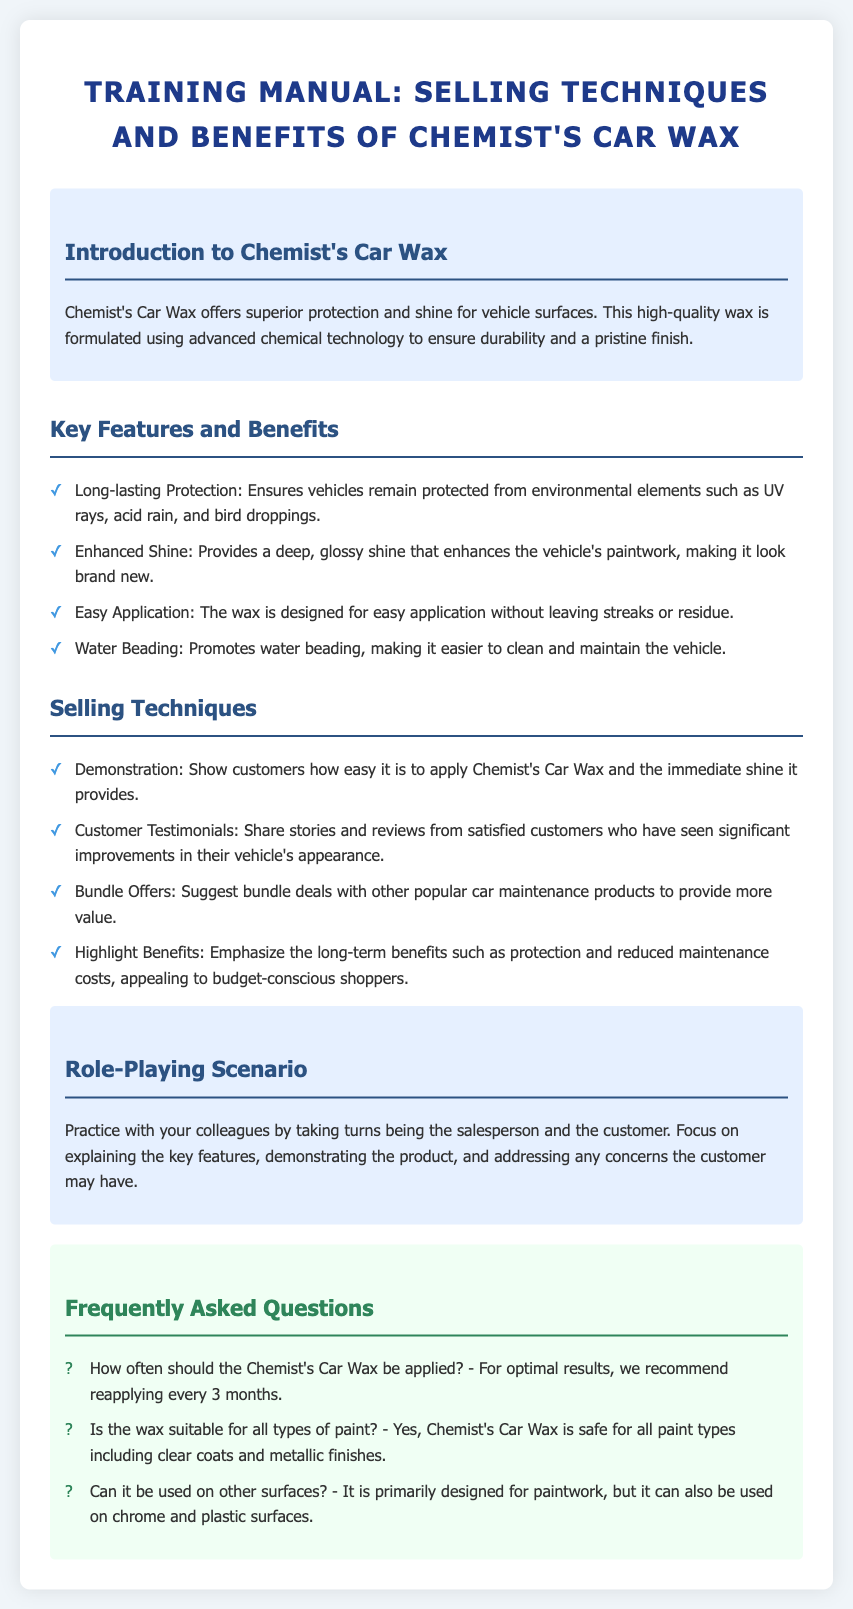What is the main benefit of Chemist's Car Wax? The main benefit is superior protection and shine for vehicle surfaces.
Answer: superior protection and shine How often should Chemist's Car Wax be reapplied? The document states that for optimal results, it is recommended to reapply every 3 months.
Answer: every 3 months What feature promotes easier cleaning of the vehicle? The feature that promotes easier cleaning is water beading.
Answer: water beading Is Chemist's Car Wax safe for metallic finishes? Yes, the document specifies that it is safe for all paint types including metallic finishes.
Answer: Yes What selling technique involves showcasing customer experiences? Showing customer experiences is highlighted under customer testimonials.
Answer: customer testimonials What is a recommended selling technique besides demonstration? A recommended technique besides demonstration is bundle offers.
Answer: bundle offers What type of surfaces can Chemist's Car Wax be used on aside from paintwork? The wax can also be used on chrome and plastic surfaces.
Answer: chrome and plastic surfaces 